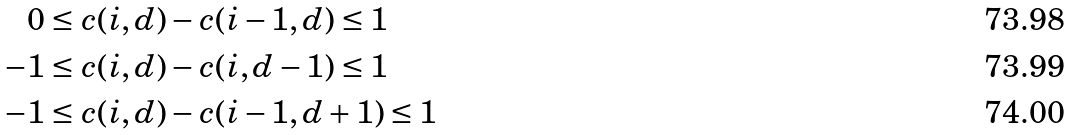Convert formula to latex. <formula><loc_0><loc_0><loc_500><loc_500>0 & \leq c ( i , d ) - c ( i - 1 , d ) \leq 1 \\ - 1 & \leq c ( i , d ) - c ( i , d - 1 ) \leq 1 \\ - 1 & \leq c ( i , d ) - c ( i - 1 , d + 1 ) \leq 1</formula> 